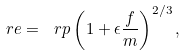<formula> <loc_0><loc_0><loc_500><loc_500>\ r e = \ r p \left ( 1 + \epsilon \frac { f } { m } \right ) ^ { 2 / 3 } ,</formula> 